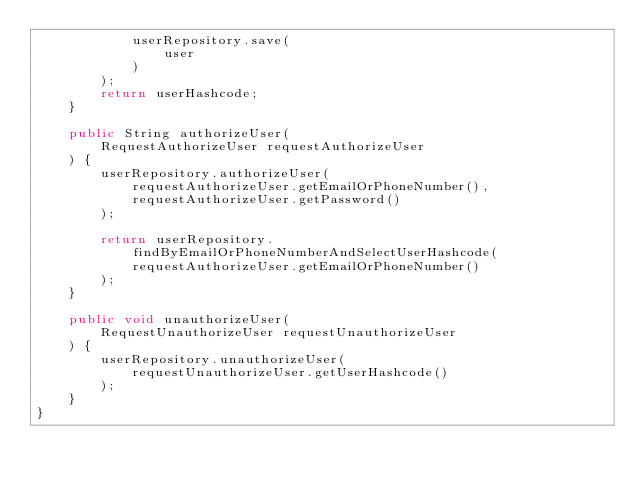Convert code to text. <code><loc_0><loc_0><loc_500><loc_500><_Java_>            userRepository.save(
                user
            )
        );
        return userHashcode;
    }
    
    public String authorizeUser(
        RequestAuthorizeUser requestAuthorizeUser
    ) {
        userRepository.authorizeUser(
            requestAuthorizeUser.getEmailOrPhoneNumber(),
            requestAuthorizeUser.getPassword()
        );
        
        return userRepository.findByEmailOrPhoneNumberAndSelectUserHashcode(
            requestAuthorizeUser.getEmailOrPhoneNumber()
        );
    }
    
    public void unauthorizeUser(
        RequestUnauthorizeUser requestUnauthorizeUser
    ) {
        userRepository.unauthorizeUser(
            requestUnauthorizeUser.getUserHashcode()
        );
    }
}
</code> 